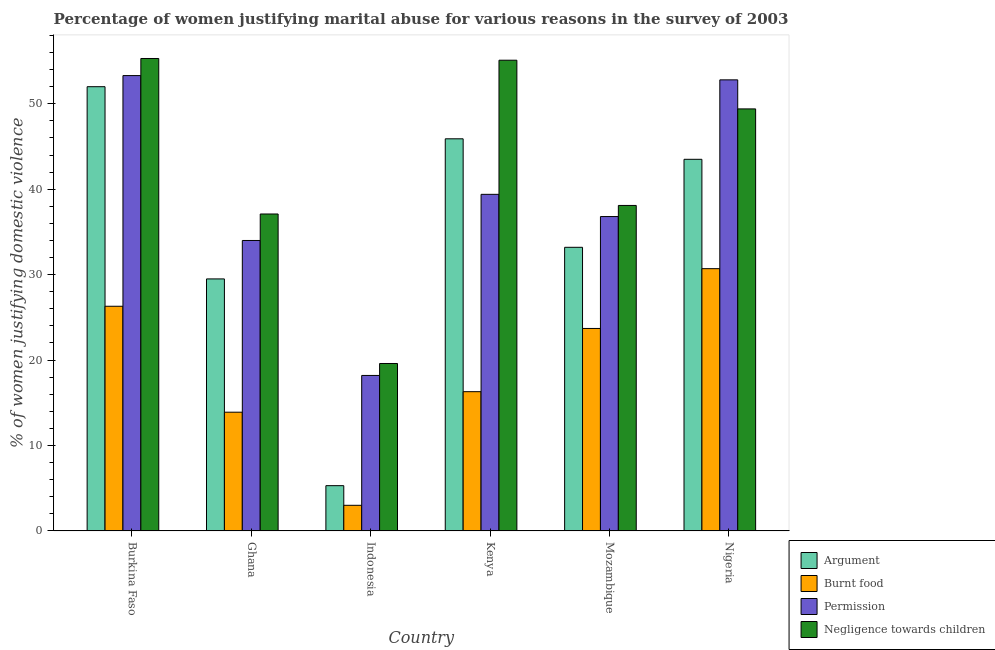How many groups of bars are there?
Offer a terse response. 6. How many bars are there on the 5th tick from the left?
Make the answer very short. 4. What is the label of the 4th group of bars from the left?
Ensure brevity in your answer.  Kenya. In how many cases, is the number of bars for a given country not equal to the number of legend labels?
Provide a succinct answer. 0. What is the percentage of women justifying abuse for showing negligence towards children in Nigeria?
Provide a short and direct response. 49.4. Across all countries, what is the maximum percentage of women justifying abuse for showing negligence towards children?
Give a very brief answer. 55.3. Across all countries, what is the minimum percentage of women justifying abuse for showing negligence towards children?
Keep it short and to the point. 19.6. In which country was the percentage of women justifying abuse for showing negligence towards children maximum?
Offer a very short reply. Burkina Faso. What is the total percentage of women justifying abuse for burning food in the graph?
Your answer should be very brief. 113.9. What is the difference between the percentage of women justifying abuse for going without permission in Burkina Faso and that in Nigeria?
Offer a very short reply. 0.5. What is the difference between the percentage of women justifying abuse for burning food in Mozambique and the percentage of women justifying abuse for going without permission in Nigeria?
Offer a terse response. -29.1. What is the average percentage of women justifying abuse in the case of an argument per country?
Ensure brevity in your answer.  34.9. What is the difference between the percentage of women justifying abuse for going without permission and percentage of women justifying abuse for burning food in Nigeria?
Your answer should be very brief. 22.1. What is the ratio of the percentage of women justifying abuse for showing negligence towards children in Kenya to that in Nigeria?
Provide a short and direct response. 1.12. Is the percentage of women justifying abuse for burning food in Ghana less than that in Indonesia?
Offer a terse response. No. Is the difference between the percentage of women justifying abuse for going without permission in Burkina Faso and Indonesia greater than the difference between the percentage of women justifying abuse for showing negligence towards children in Burkina Faso and Indonesia?
Your answer should be compact. No. What is the difference between the highest and the second highest percentage of women justifying abuse for showing negligence towards children?
Your answer should be very brief. 0.2. What is the difference between the highest and the lowest percentage of women justifying abuse in the case of an argument?
Your response must be concise. 46.7. What does the 2nd bar from the left in Ghana represents?
Offer a terse response. Burnt food. What does the 3rd bar from the right in Nigeria represents?
Your answer should be very brief. Burnt food. What is the difference between two consecutive major ticks on the Y-axis?
Ensure brevity in your answer.  10. Does the graph contain any zero values?
Offer a very short reply. No. How many legend labels are there?
Ensure brevity in your answer.  4. What is the title of the graph?
Your answer should be compact. Percentage of women justifying marital abuse for various reasons in the survey of 2003. What is the label or title of the Y-axis?
Provide a short and direct response. % of women justifying domestic violence. What is the % of women justifying domestic violence in Burnt food in Burkina Faso?
Offer a terse response. 26.3. What is the % of women justifying domestic violence of Permission in Burkina Faso?
Your answer should be compact. 53.3. What is the % of women justifying domestic violence of Negligence towards children in Burkina Faso?
Your response must be concise. 55.3. What is the % of women justifying domestic violence in Argument in Ghana?
Provide a short and direct response. 29.5. What is the % of women justifying domestic violence of Burnt food in Ghana?
Keep it short and to the point. 13.9. What is the % of women justifying domestic violence of Negligence towards children in Ghana?
Your answer should be compact. 37.1. What is the % of women justifying domestic violence of Argument in Indonesia?
Offer a terse response. 5.3. What is the % of women justifying domestic violence of Burnt food in Indonesia?
Your response must be concise. 3. What is the % of women justifying domestic violence of Permission in Indonesia?
Your response must be concise. 18.2. What is the % of women justifying domestic violence of Negligence towards children in Indonesia?
Your answer should be compact. 19.6. What is the % of women justifying domestic violence of Argument in Kenya?
Provide a short and direct response. 45.9. What is the % of women justifying domestic violence in Permission in Kenya?
Keep it short and to the point. 39.4. What is the % of women justifying domestic violence in Negligence towards children in Kenya?
Your response must be concise. 55.1. What is the % of women justifying domestic violence of Argument in Mozambique?
Your answer should be compact. 33.2. What is the % of women justifying domestic violence of Burnt food in Mozambique?
Make the answer very short. 23.7. What is the % of women justifying domestic violence in Permission in Mozambique?
Make the answer very short. 36.8. What is the % of women justifying domestic violence in Negligence towards children in Mozambique?
Ensure brevity in your answer.  38.1. What is the % of women justifying domestic violence of Argument in Nigeria?
Give a very brief answer. 43.5. What is the % of women justifying domestic violence in Burnt food in Nigeria?
Provide a short and direct response. 30.7. What is the % of women justifying domestic violence of Permission in Nigeria?
Make the answer very short. 52.8. What is the % of women justifying domestic violence in Negligence towards children in Nigeria?
Give a very brief answer. 49.4. Across all countries, what is the maximum % of women justifying domestic violence in Burnt food?
Your answer should be compact. 30.7. Across all countries, what is the maximum % of women justifying domestic violence of Permission?
Give a very brief answer. 53.3. Across all countries, what is the maximum % of women justifying domestic violence in Negligence towards children?
Offer a very short reply. 55.3. Across all countries, what is the minimum % of women justifying domestic violence of Argument?
Your answer should be compact. 5.3. Across all countries, what is the minimum % of women justifying domestic violence in Burnt food?
Your answer should be very brief. 3. Across all countries, what is the minimum % of women justifying domestic violence of Negligence towards children?
Offer a terse response. 19.6. What is the total % of women justifying domestic violence of Argument in the graph?
Provide a succinct answer. 209.4. What is the total % of women justifying domestic violence of Burnt food in the graph?
Offer a terse response. 113.9. What is the total % of women justifying domestic violence in Permission in the graph?
Give a very brief answer. 234.5. What is the total % of women justifying domestic violence of Negligence towards children in the graph?
Provide a succinct answer. 254.6. What is the difference between the % of women justifying domestic violence of Argument in Burkina Faso and that in Ghana?
Your answer should be very brief. 22.5. What is the difference between the % of women justifying domestic violence in Permission in Burkina Faso and that in Ghana?
Your answer should be very brief. 19.3. What is the difference between the % of women justifying domestic violence in Argument in Burkina Faso and that in Indonesia?
Ensure brevity in your answer.  46.7. What is the difference between the % of women justifying domestic violence of Burnt food in Burkina Faso and that in Indonesia?
Offer a very short reply. 23.3. What is the difference between the % of women justifying domestic violence of Permission in Burkina Faso and that in Indonesia?
Provide a short and direct response. 35.1. What is the difference between the % of women justifying domestic violence in Negligence towards children in Burkina Faso and that in Indonesia?
Make the answer very short. 35.7. What is the difference between the % of women justifying domestic violence of Argument in Burkina Faso and that in Mozambique?
Provide a succinct answer. 18.8. What is the difference between the % of women justifying domestic violence of Permission in Burkina Faso and that in Mozambique?
Make the answer very short. 16.5. What is the difference between the % of women justifying domestic violence of Negligence towards children in Burkina Faso and that in Mozambique?
Give a very brief answer. 17.2. What is the difference between the % of women justifying domestic violence in Argument in Burkina Faso and that in Nigeria?
Your response must be concise. 8.5. What is the difference between the % of women justifying domestic violence of Negligence towards children in Burkina Faso and that in Nigeria?
Offer a terse response. 5.9. What is the difference between the % of women justifying domestic violence in Argument in Ghana and that in Indonesia?
Provide a short and direct response. 24.2. What is the difference between the % of women justifying domestic violence in Burnt food in Ghana and that in Indonesia?
Give a very brief answer. 10.9. What is the difference between the % of women justifying domestic violence in Argument in Ghana and that in Kenya?
Your response must be concise. -16.4. What is the difference between the % of women justifying domestic violence of Permission in Ghana and that in Kenya?
Your answer should be very brief. -5.4. What is the difference between the % of women justifying domestic violence of Negligence towards children in Ghana and that in Kenya?
Your answer should be very brief. -18. What is the difference between the % of women justifying domestic violence of Permission in Ghana and that in Mozambique?
Ensure brevity in your answer.  -2.8. What is the difference between the % of women justifying domestic violence of Argument in Ghana and that in Nigeria?
Ensure brevity in your answer.  -14. What is the difference between the % of women justifying domestic violence in Burnt food in Ghana and that in Nigeria?
Provide a succinct answer. -16.8. What is the difference between the % of women justifying domestic violence in Permission in Ghana and that in Nigeria?
Your answer should be compact. -18.8. What is the difference between the % of women justifying domestic violence of Argument in Indonesia and that in Kenya?
Ensure brevity in your answer.  -40.6. What is the difference between the % of women justifying domestic violence of Burnt food in Indonesia and that in Kenya?
Offer a very short reply. -13.3. What is the difference between the % of women justifying domestic violence of Permission in Indonesia and that in Kenya?
Offer a very short reply. -21.2. What is the difference between the % of women justifying domestic violence of Negligence towards children in Indonesia and that in Kenya?
Offer a terse response. -35.5. What is the difference between the % of women justifying domestic violence in Argument in Indonesia and that in Mozambique?
Provide a succinct answer. -27.9. What is the difference between the % of women justifying domestic violence of Burnt food in Indonesia and that in Mozambique?
Offer a terse response. -20.7. What is the difference between the % of women justifying domestic violence in Permission in Indonesia and that in Mozambique?
Offer a very short reply. -18.6. What is the difference between the % of women justifying domestic violence in Negligence towards children in Indonesia and that in Mozambique?
Your response must be concise. -18.5. What is the difference between the % of women justifying domestic violence in Argument in Indonesia and that in Nigeria?
Provide a short and direct response. -38.2. What is the difference between the % of women justifying domestic violence in Burnt food in Indonesia and that in Nigeria?
Offer a very short reply. -27.7. What is the difference between the % of women justifying domestic violence of Permission in Indonesia and that in Nigeria?
Offer a very short reply. -34.6. What is the difference between the % of women justifying domestic violence of Negligence towards children in Indonesia and that in Nigeria?
Provide a short and direct response. -29.8. What is the difference between the % of women justifying domestic violence in Negligence towards children in Kenya and that in Mozambique?
Keep it short and to the point. 17. What is the difference between the % of women justifying domestic violence of Burnt food in Kenya and that in Nigeria?
Ensure brevity in your answer.  -14.4. What is the difference between the % of women justifying domestic violence of Argument in Mozambique and that in Nigeria?
Keep it short and to the point. -10.3. What is the difference between the % of women justifying domestic violence in Permission in Mozambique and that in Nigeria?
Give a very brief answer. -16. What is the difference between the % of women justifying domestic violence in Argument in Burkina Faso and the % of women justifying domestic violence in Burnt food in Ghana?
Ensure brevity in your answer.  38.1. What is the difference between the % of women justifying domestic violence in Argument in Burkina Faso and the % of women justifying domestic violence in Permission in Ghana?
Ensure brevity in your answer.  18. What is the difference between the % of women justifying domestic violence of Burnt food in Burkina Faso and the % of women justifying domestic violence of Permission in Ghana?
Your answer should be very brief. -7.7. What is the difference between the % of women justifying domestic violence in Burnt food in Burkina Faso and the % of women justifying domestic violence in Negligence towards children in Ghana?
Provide a succinct answer. -10.8. What is the difference between the % of women justifying domestic violence in Argument in Burkina Faso and the % of women justifying domestic violence in Burnt food in Indonesia?
Provide a short and direct response. 49. What is the difference between the % of women justifying domestic violence of Argument in Burkina Faso and the % of women justifying domestic violence of Permission in Indonesia?
Make the answer very short. 33.8. What is the difference between the % of women justifying domestic violence in Argument in Burkina Faso and the % of women justifying domestic violence in Negligence towards children in Indonesia?
Provide a short and direct response. 32.4. What is the difference between the % of women justifying domestic violence in Permission in Burkina Faso and the % of women justifying domestic violence in Negligence towards children in Indonesia?
Your response must be concise. 33.7. What is the difference between the % of women justifying domestic violence in Argument in Burkina Faso and the % of women justifying domestic violence in Burnt food in Kenya?
Keep it short and to the point. 35.7. What is the difference between the % of women justifying domestic violence in Argument in Burkina Faso and the % of women justifying domestic violence in Negligence towards children in Kenya?
Ensure brevity in your answer.  -3.1. What is the difference between the % of women justifying domestic violence of Burnt food in Burkina Faso and the % of women justifying domestic violence of Permission in Kenya?
Give a very brief answer. -13.1. What is the difference between the % of women justifying domestic violence of Burnt food in Burkina Faso and the % of women justifying domestic violence of Negligence towards children in Kenya?
Offer a very short reply. -28.8. What is the difference between the % of women justifying domestic violence of Permission in Burkina Faso and the % of women justifying domestic violence of Negligence towards children in Kenya?
Keep it short and to the point. -1.8. What is the difference between the % of women justifying domestic violence in Argument in Burkina Faso and the % of women justifying domestic violence in Burnt food in Mozambique?
Offer a terse response. 28.3. What is the difference between the % of women justifying domestic violence in Argument in Burkina Faso and the % of women justifying domestic violence in Permission in Mozambique?
Provide a short and direct response. 15.2. What is the difference between the % of women justifying domestic violence in Argument in Burkina Faso and the % of women justifying domestic violence in Burnt food in Nigeria?
Provide a succinct answer. 21.3. What is the difference between the % of women justifying domestic violence of Burnt food in Burkina Faso and the % of women justifying domestic violence of Permission in Nigeria?
Your response must be concise. -26.5. What is the difference between the % of women justifying domestic violence of Burnt food in Burkina Faso and the % of women justifying domestic violence of Negligence towards children in Nigeria?
Make the answer very short. -23.1. What is the difference between the % of women justifying domestic violence of Argument in Ghana and the % of women justifying domestic violence of Burnt food in Indonesia?
Provide a short and direct response. 26.5. What is the difference between the % of women justifying domestic violence in Argument in Ghana and the % of women justifying domestic violence in Permission in Indonesia?
Offer a very short reply. 11.3. What is the difference between the % of women justifying domestic violence in Permission in Ghana and the % of women justifying domestic violence in Negligence towards children in Indonesia?
Provide a short and direct response. 14.4. What is the difference between the % of women justifying domestic violence in Argument in Ghana and the % of women justifying domestic violence in Negligence towards children in Kenya?
Your response must be concise. -25.6. What is the difference between the % of women justifying domestic violence in Burnt food in Ghana and the % of women justifying domestic violence in Permission in Kenya?
Ensure brevity in your answer.  -25.5. What is the difference between the % of women justifying domestic violence of Burnt food in Ghana and the % of women justifying domestic violence of Negligence towards children in Kenya?
Provide a succinct answer. -41.2. What is the difference between the % of women justifying domestic violence in Permission in Ghana and the % of women justifying domestic violence in Negligence towards children in Kenya?
Ensure brevity in your answer.  -21.1. What is the difference between the % of women justifying domestic violence in Argument in Ghana and the % of women justifying domestic violence in Burnt food in Mozambique?
Provide a short and direct response. 5.8. What is the difference between the % of women justifying domestic violence of Burnt food in Ghana and the % of women justifying domestic violence of Permission in Mozambique?
Offer a very short reply. -22.9. What is the difference between the % of women justifying domestic violence in Burnt food in Ghana and the % of women justifying domestic violence in Negligence towards children in Mozambique?
Your response must be concise. -24.2. What is the difference between the % of women justifying domestic violence of Permission in Ghana and the % of women justifying domestic violence of Negligence towards children in Mozambique?
Your answer should be compact. -4.1. What is the difference between the % of women justifying domestic violence of Argument in Ghana and the % of women justifying domestic violence of Permission in Nigeria?
Provide a succinct answer. -23.3. What is the difference between the % of women justifying domestic violence in Argument in Ghana and the % of women justifying domestic violence in Negligence towards children in Nigeria?
Provide a short and direct response. -19.9. What is the difference between the % of women justifying domestic violence of Burnt food in Ghana and the % of women justifying domestic violence of Permission in Nigeria?
Ensure brevity in your answer.  -38.9. What is the difference between the % of women justifying domestic violence in Burnt food in Ghana and the % of women justifying domestic violence in Negligence towards children in Nigeria?
Your answer should be compact. -35.5. What is the difference between the % of women justifying domestic violence of Permission in Ghana and the % of women justifying domestic violence of Negligence towards children in Nigeria?
Give a very brief answer. -15.4. What is the difference between the % of women justifying domestic violence of Argument in Indonesia and the % of women justifying domestic violence of Burnt food in Kenya?
Your response must be concise. -11. What is the difference between the % of women justifying domestic violence of Argument in Indonesia and the % of women justifying domestic violence of Permission in Kenya?
Offer a terse response. -34.1. What is the difference between the % of women justifying domestic violence in Argument in Indonesia and the % of women justifying domestic violence in Negligence towards children in Kenya?
Make the answer very short. -49.8. What is the difference between the % of women justifying domestic violence of Burnt food in Indonesia and the % of women justifying domestic violence of Permission in Kenya?
Your answer should be compact. -36.4. What is the difference between the % of women justifying domestic violence in Burnt food in Indonesia and the % of women justifying domestic violence in Negligence towards children in Kenya?
Your response must be concise. -52.1. What is the difference between the % of women justifying domestic violence of Permission in Indonesia and the % of women justifying domestic violence of Negligence towards children in Kenya?
Ensure brevity in your answer.  -36.9. What is the difference between the % of women justifying domestic violence of Argument in Indonesia and the % of women justifying domestic violence of Burnt food in Mozambique?
Your answer should be compact. -18.4. What is the difference between the % of women justifying domestic violence of Argument in Indonesia and the % of women justifying domestic violence of Permission in Mozambique?
Offer a terse response. -31.5. What is the difference between the % of women justifying domestic violence of Argument in Indonesia and the % of women justifying domestic violence of Negligence towards children in Mozambique?
Keep it short and to the point. -32.8. What is the difference between the % of women justifying domestic violence in Burnt food in Indonesia and the % of women justifying domestic violence in Permission in Mozambique?
Your answer should be very brief. -33.8. What is the difference between the % of women justifying domestic violence in Burnt food in Indonesia and the % of women justifying domestic violence in Negligence towards children in Mozambique?
Make the answer very short. -35.1. What is the difference between the % of women justifying domestic violence of Permission in Indonesia and the % of women justifying domestic violence of Negligence towards children in Mozambique?
Keep it short and to the point. -19.9. What is the difference between the % of women justifying domestic violence of Argument in Indonesia and the % of women justifying domestic violence of Burnt food in Nigeria?
Offer a terse response. -25.4. What is the difference between the % of women justifying domestic violence in Argument in Indonesia and the % of women justifying domestic violence in Permission in Nigeria?
Your answer should be very brief. -47.5. What is the difference between the % of women justifying domestic violence of Argument in Indonesia and the % of women justifying domestic violence of Negligence towards children in Nigeria?
Make the answer very short. -44.1. What is the difference between the % of women justifying domestic violence in Burnt food in Indonesia and the % of women justifying domestic violence in Permission in Nigeria?
Your answer should be compact. -49.8. What is the difference between the % of women justifying domestic violence of Burnt food in Indonesia and the % of women justifying domestic violence of Negligence towards children in Nigeria?
Your answer should be very brief. -46.4. What is the difference between the % of women justifying domestic violence of Permission in Indonesia and the % of women justifying domestic violence of Negligence towards children in Nigeria?
Ensure brevity in your answer.  -31.2. What is the difference between the % of women justifying domestic violence in Argument in Kenya and the % of women justifying domestic violence in Burnt food in Mozambique?
Your answer should be very brief. 22.2. What is the difference between the % of women justifying domestic violence of Argument in Kenya and the % of women justifying domestic violence of Negligence towards children in Mozambique?
Your answer should be compact. 7.8. What is the difference between the % of women justifying domestic violence of Burnt food in Kenya and the % of women justifying domestic violence of Permission in Mozambique?
Make the answer very short. -20.5. What is the difference between the % of women justifying domestic violence of Burnt food in Kenya and the % of women justifying domestic violence of Negligence towards children in Mozambique?
Your answer should be very brief. -21.8. What is the difference between the % of women justifying domestic violence in Burnt food in Kenya and the % of women justifying domestic violence in Permission in Nigeria?
Provide a short and direct response. -36.5. What is the difference between the % of women justifying domestic violence in Burnt food in Kenya and the % of women justifying domestic violence in Negligence towards children in Nigeria?
Offer a terse response. -33.1. What is the difference between the % of women justifying domestic violence in Argument in Mozambique and the % of women justifying domestic violence in Burnt food in Nigeria?
Offer a very short reply. 2.5. What is the difference between the % of women justifying domestic violence of Argument in Mozambique and the % of women justifying domestic violence of Permission in Nigeria?
Make the answer very short. -19.6. What is the difference between the % of women justifying domestic violence of Argument in Mozambique and the % of women justifying domestic violence of Negligence towards children in Nigeria?
Offer a very short reply. -16.2. What is the difference between the % of women justifying domestic violence in Burnt food in Mozambique and the % of women justifying domestic violence in Permission in Nigeria?
Your answer should be very brief. -29.1. What is the difference between the % of women justifying domestic violence of Burnt food in Mozambique and the % of women justifying domestic violence of Negligence towards children in Nigeria?
Ensure brevity in your answer.  -25.7. What is the difference between the % of women justifying domestic violence of Permission in Mozambique and the % of women justifying domestic violence of Negligence towards children in Nigeria?
Offer a very short reply. -12.6. What is the average % of women justifying domestic violence of Argument per country?
Provide a short and direct response. 34.9. What is the average % of women justifying domestic violence of Burnt food per country?
Give a very brief answer. 18.98. What is the average % of women justifying domestic violence of Permission per country?
Provide a succinct answer. 39.08. What is the average % of women justifying domestic violence of Negligence towards children per country?
Your response must be concise. 42.43. What is the difference between the % of women justifying domestic violence of Argument and % of women justifying domestic violence of Burnt food in Burkina Faso?
Offer a very short reply. 25.7. What is the difference between the % of women justifying domestic violence of Burnt food and % of women justifying domestic violence of Negligence towards children in Burkina Faso?
Your answer should be very brief. -29. What is the difference between the % of women justifying domestic violence in Permission and % of women justifying domestic violence in Negligence towards children in Burkina Faso?
Ensure brevity in your answer.  -2. What is the difference between the % of women justifying domestic violence in Burnt food and % of women justifying domestic violence in Permission in Ghana?
Offer a very short reply. -20.1. What is the difference between the % of women justifying domestic violence in Burnt food and % of women justifying domestic violence in Negligence towards children in Ghana?
Your answer should be compact. -23.2. What is the difference between the % of women justifying domestic violence in Argument and % of women justifying domestic violence in Burnt food in Indonesia?
Give a very brief answer. 2.3. What is the difference between the % of women justifying domestic violence of Argument and % of women justifying domestic violence of Permission in Indonesia?
Keep it short and to the point. -12.9. What is the difference between the % of women justifying domestic violence in Argument and % of women justifying domestic violence in Negligence towards children in Indonesia?
Give a very brief answer. -14.3. What is the difference between the % of women justifying domestic violence of Burnt food and % of women justifying domestic violence of Permission in Indonesia?
Offer a very short reply. -15.2. What is the difference between the % of women justifying domestic violence in Burnt food and % of women justifying domestic violence in Negligence towards children in Indonesia?
Your answer should be compact. -16.6. What is the difference between the % of women justifying domestic violence in Argument and % of women justifying domestic violence in Burnt food in Kenya?
Provide a short and direct response. 29.6. What is the difference between the % of women justifying domestic violence in Burnt food and % of women justifying domestic violence in Permission in Kenya?
Offer a terse response. -23.1. What is the difference between the % of women justifying domestic violence in Burnt food and % of women justifying domestic violence in Negligence towards children in Kenya?
Keep it short and to the point. -38.8. What is the difference between the % of women justifying domestic violence in Permission and % of women justifying domestic violence in Negligence towards children in Kenya?
Your answer should be very brief. -15.7. What is the difference between the % of women justifying domestic violence in Argument and % of women justifying domestic violence in Permission in Mozambique?
Your answer should be very brief. -3.6. What is the difference between the % of women justifying domestic violence of Argument and % of women justifying domestic violence of Negligence towards children in Mozambique?
Offer a very short reply. -4.9. What is the difference between the % of women justifying domestic violence of Burnt food and % of women justifying domestic violence of Permission in Mozambique?
Give a very brief answer. -13.1. What is the difference between the % of women justifying domestic violence in Burnt food and % of women justifying domestic violence in Negligence towards children in Mozambique?
Make the answer very short. -14.4. What is the difference between the % of women justifying domestic violence in Permission and % of women justifying domestic violence in Negligence towards children in Mozambique?
Make the answer very short. -1.3. What is the difference between the % of women justifying domestic violence in Argument and % of women justifying domestic violence in Permission in Nigeria?
Ensure brevity in your answer.  -9.3. What is the difference between the % of women justifying domestic violence of Burnt food and % of women justifying domestic violence of Permission in Nigeria?
Offer a terse response. -22.1. What is the difference between the % of women justifying domestic violence of Burnt food and % of women justifying domestic violence of Negligence towards children in Nigeria?
Your answer should be very brief. -18.7. What is the ratio of the % of women justifying domestic violence of Argument in Burkina Faso to that in Ghana?
Your response must be concise. 1.76. What is the ratio of the % of women justifying domestic violence in Burnt food in Burkina Faso to that in Ghana?
Keep it short and to the point. 1.89. What is the ratio of the % of women justifying domestic violence in Permission in Burkina Faso to that in Ghana?
Give a very brief answer. 1.57. What is the ratio of the % of women justifying domestic violence of Negligence towards children in Burkina Faso to that in Ghana?
Offer a terse response. 1.49. What is the ratio of the % of women justifying domestic violence of Argument in Burkina Faso to that in Indonesia?
Your answer should be very brief. 9.81. What is the ratio of the % of women justifying domestic violence in Burnt food in Burkina Faso to that in Indonesia?
Your answer should be compact. 8.77. What is the ratio of the % of women justifying domestic violence in Permission in Burkina Faso to that in Indonesia?
Your answer should be very brief. 2.93. What is the ratio of the % of women justifying domestic violence in Negligence towards children in Burkina Faso to that in Indonesia?
Your answer should be compact. 2.82. What is the ratio of the % of women justifying domestic violence of Argument in Burkina Faso to that in Kenya?
Offer a terse response. 1.13. What is the ratio of the % of women justifying domestic violence of Burnt food in Burkina Faso to that in Kenya?
Your response must be concise. 1.61. What is the ratio of the % of women justifying domestic violence of Permission in Burkina Faso to that in Kenya?
Your response must be concise. 1.35. What is the ratio of the % of women justifying domestic violence of Argument in Burkina Faso to that in Mozambique?
Provide a succinct answer. 1.57. What is the ratio of the % of women justifying domestic violence in Burnt food in Burkina Faso to that in Mozambique?
Offer a terse response. 1.11. What is the ratio of the % of women justifying domestic violence of Permission in Burkina Faso to that in Mozambique?
Your response must be concise. 1.45. What is the ratio of the % of women justifying domestic violence in Negligence towards children in Burkina Faso to that in Mozambique?
Provide a succinct answer. 1.45. What is the ratio of the % of women justifying domestic violence in Argument in Burkina Faso to that in Nigeria?
Make the answer very short. 1.2. What is the ratio of the % of women justifying domestic violence of Burnt food in Burkina Faso to that in Nigeria?
Your response must be concise. 0.86. What is the ratio of the % of women justifying domestic violence in Permission in Burkina Faso to that in Nigeria?
Your response must be concise. 1.01. What is the ratio of the % of women justifying domestic violence in Negligence towards children in Burkina Faso to that in Nigeria?
Provide a succinct answer. 1.12. What is the ratio of the % of women justifying domestic violence of Argument in Ghana to that in Indonesia?
Keep it short and to the point. 5.57. What is the ratio of the % of women justifying domestic violence of Burnt food in Ghana to that in Indonesia?
Ensure brevity in your answer.  4.63. What is the ratio of the % of women justifying domestic violence in Permission in Ghana to that in Indonesia?
Offer a terse response. 1.87. What is the ratio of the % of women justifying domestic violence in Negligence towards children in Ghana to that in Indonesia?
Ensure brevity in your answer.  1.89. What is the ratio of the % of women justifying domestic violence of Argument in Ghana to that in Kenya?
Your answer should be very brief. 0.64. What is the ratio of the % of women justifying domestic violence in Burnt food in Ghana to that in Kenya?
Make the answer very short. 0.85. What is the ratio of the % of women justifying domestic violence of Permission in Ghana to that in Kenya?
Offer a very short reply. 0.86. What is the ratio of the % of women justifying domestic violence of Negligence towards children in Ghana to that in Kenya?
Provide a succinct answer. 0.67. What is the ratio of the % of women justifying domestic violence of Argument in Ghana to that in Mozambique?
Make the answer very short. 0.89. What is the ratio of the % of women justifying domestic violence of Burnt food in Ghana to that in Mozambique?
Your answer should be compact. 0.59. What is the ratio of the % of women justifying domestic violence in Permission in Ghana to that in Mozambique?
Ensure brevity in your answer.  0.92. What is the ratio of the % of women justifying domestic violence in Negligence towards children in Ghana to that in Mozambique?
Offer a very short reply. 0.97. What is the ratio of the % of women justifying domestic violence of Argument in Ghana to that in Nigeria?
Keep it short and to the point. 0.68. What is the ratio of the % of women justifying domestic violence of Burnt food in Ghana to that in Nigeria?
Make the answer very short. 0.45. What is the ratio of the % of women justifying domestic violence of Permission in Ghana to that in Nigeria?
Your answer should be very brief. 0.64. What is the ratio of the % of women justifying domestic violence of Negligence towards children in Ghana to that in Nigeria?
Keep it short and to the point. 0.75. What is the ratio of the % of women justifying domestic violence of Argument in Indonesia to that in Kenya?
Your answer should be very brief. 0.12. What is the ratio of the % of women justifying domestic violence in Burnt food in Indonesia to that in Kenya?
Keep it short and to the point. 0.18. What is the ratio of the % of women justifying domestic violence of Permission in Indonesia to that in Kenya?
Keep it short and to the point. 0.46. What is the ratio of the % of women justifying domestic violence in Negligence towards children in Indonesia to that in Kenya?
Make the answer very short. 0.36. What is the ratio of the % of women justifying domestic violence in Argument in Indonesia to that in Mozambique?
Provide a short and direct response. 0.16. What is the ratio of the % of women justifying domestic violence of Burnt food in Indonesia to that in Mozambique?
Provide a succinct answer. 0.13. What is the ratio of the % of women justifying domestic violence of Permission in Indonesia to that in Mozambique?
Offer a terse response. 0.49. What is the ratio of the % of women justifying domestic violence of Negligence towards children in Indonesia to that in Mozambique?
Provide a succinct answer. 0.51. What is the ratio of the % of women justifying domestic violence in Argument in Indonesia to that in Nigeria?
Keep it short and to the point. 0.12. What is the ratio of the % of women justifying domestic violence in Burnt food in Indonesia to that in Nigeria?
Offer a terse response. 0.1. What is the ratio of the % of women justifying domestic violence of Permission in Indonesia to that in Nigeria?
Offer a terse response. 0.34. What is the ratio of the % of women justifying domestic violence in Negligence towards children in Indonesia to that in Nigeria?
Ensure brevity in your answer.  0.4. What is the ratio of the % of women justifying domestic violence in Argument in Kenya to that in Mozambique?
Offer a very short reply. 1.38. What is the ratio of the % of women justifying domestic violence of Burnt food in Kenya to that in Mozambique?
Ensure brevity in your answer.  0.69. What is the ratio of the % of women justifying domestic violence of Permission in Kenya to that in Mozambique?
Your response must be concise. 1.07. What is the ratio of the % of women justifying domestic violence of Negligence towards children in Kenya to that in Mozambique?
Offer a terse response. 1.45. What is the ratio of the % of women justifying domestic violence in Argument in Kenya to that in Nigeria?
Your answer should be compact. 1.06. What is the ratio of the % of women justifying domestic violence of Burnt food in Kenya to that in Nigeria?
Provide a succinct answer. 0.53. What is the ratio of the % of women justifying domestic violence of Permission in Kenya to that in Nigeria?
Make the answer very short. 0.75. What is the ratio of the % of women justifying domestic violence of Negligence towards children in Kenya to that in Nigeria?
Ensure brevity in your answer.  1.12. What is the ratio of the % of women justifying domestic violence in Argument in Mozambique to that in Nigeria?
Make the answer very short. 0.76. What is the ratio of the % of women justifying domestic violence in Burnt food in Mozambique to that in Nigeria?
Keep it short and to the point. 0.77. What is the ratio of the % of women justifying domestic violence of Permission in Mozambique to that in Nigeria?
Offer a terse response. 0.7. What is the ratio of the % of women justifying domestic violence in Negligence towards children in Mozambique to that in Nigeria?
Provide a short and direct response. 0.77. What is the difference between the highest and the second highest % of women justifying domestic violence in Permission?
Your response must be concise. 0.5. What is the difference between the highest and the second highest % of women justifying domestic violence of Negligence towards children?
Your response must be concise. 0.2. What is the difference between the highest and the lowest % of women justifying domestic violence in Argument?
Your answer should be compact. 46.7. What is the difference between the highest and the lowest % of women justifying domestic violence in Burnt food?
Your response must be concise. 27.7. What is the difference between the highest and the lowest % of women justifying domestic violence of Permission?
Your response must be concise. 35.1. What is the difference between the highest and the lowest % of women justifying domestic violence in Negligence towards children?
Provide a short and direct response. 35.7. 